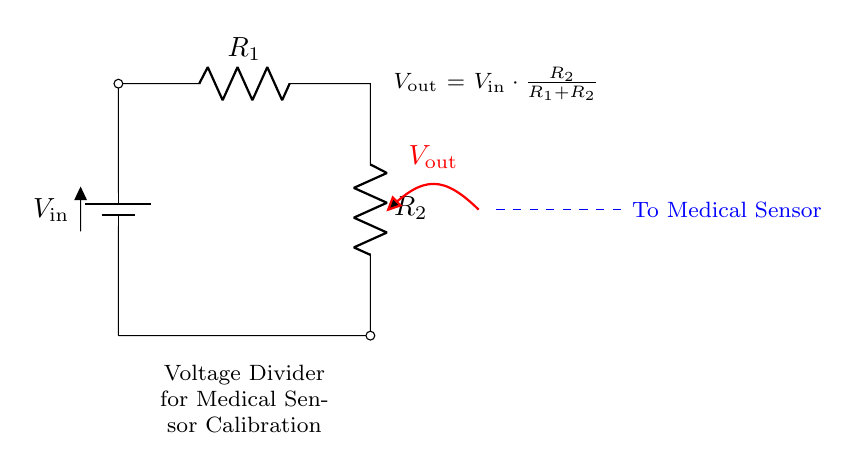What is the input voltage in this circuit? The input voltage is represented as V_in, which is at the top of the battery in the diagram. It is the source voltage for the voltage divider.
Answer: V_in What are the resistor values in this circuit? The resistors are labeled R_1 and R_2 in the circuit diagram. These are the two resistors that make up the voltage divider.
Answer: R_1, R_2 What does V_out represent in this circuit? V_out is labeled at the midpoint of the two resistors and represents the output voltage of the voltage divider. It is the voltage measured across R_2.
Answer: V_out What is the relationship between V_out and V_in? The relationship is given by the formula V_out = V_in * (R_2 / (R_1 + R_2)), which calculates the output voltage based on the input voltage and the resistor values.
Answer: V_out = V_in * (R_2 / (R_1 + R_2)) If R_1 is much larger than R_2, what happens to V_out? If R_1 is significantly larger than R_2, then V_out approaches zero, indicating that most of the voltage drops across R_1, and very little voltage is left for R_2.
Answer: V_out approaches zero How is the output of this voltage divider used? The output V_out is indicated to be connected to a medical sensor, suggesting that it is used to supply a calibrated voltage for operational purposes within the sensor circuit.
Answer: To Medical Sensor 